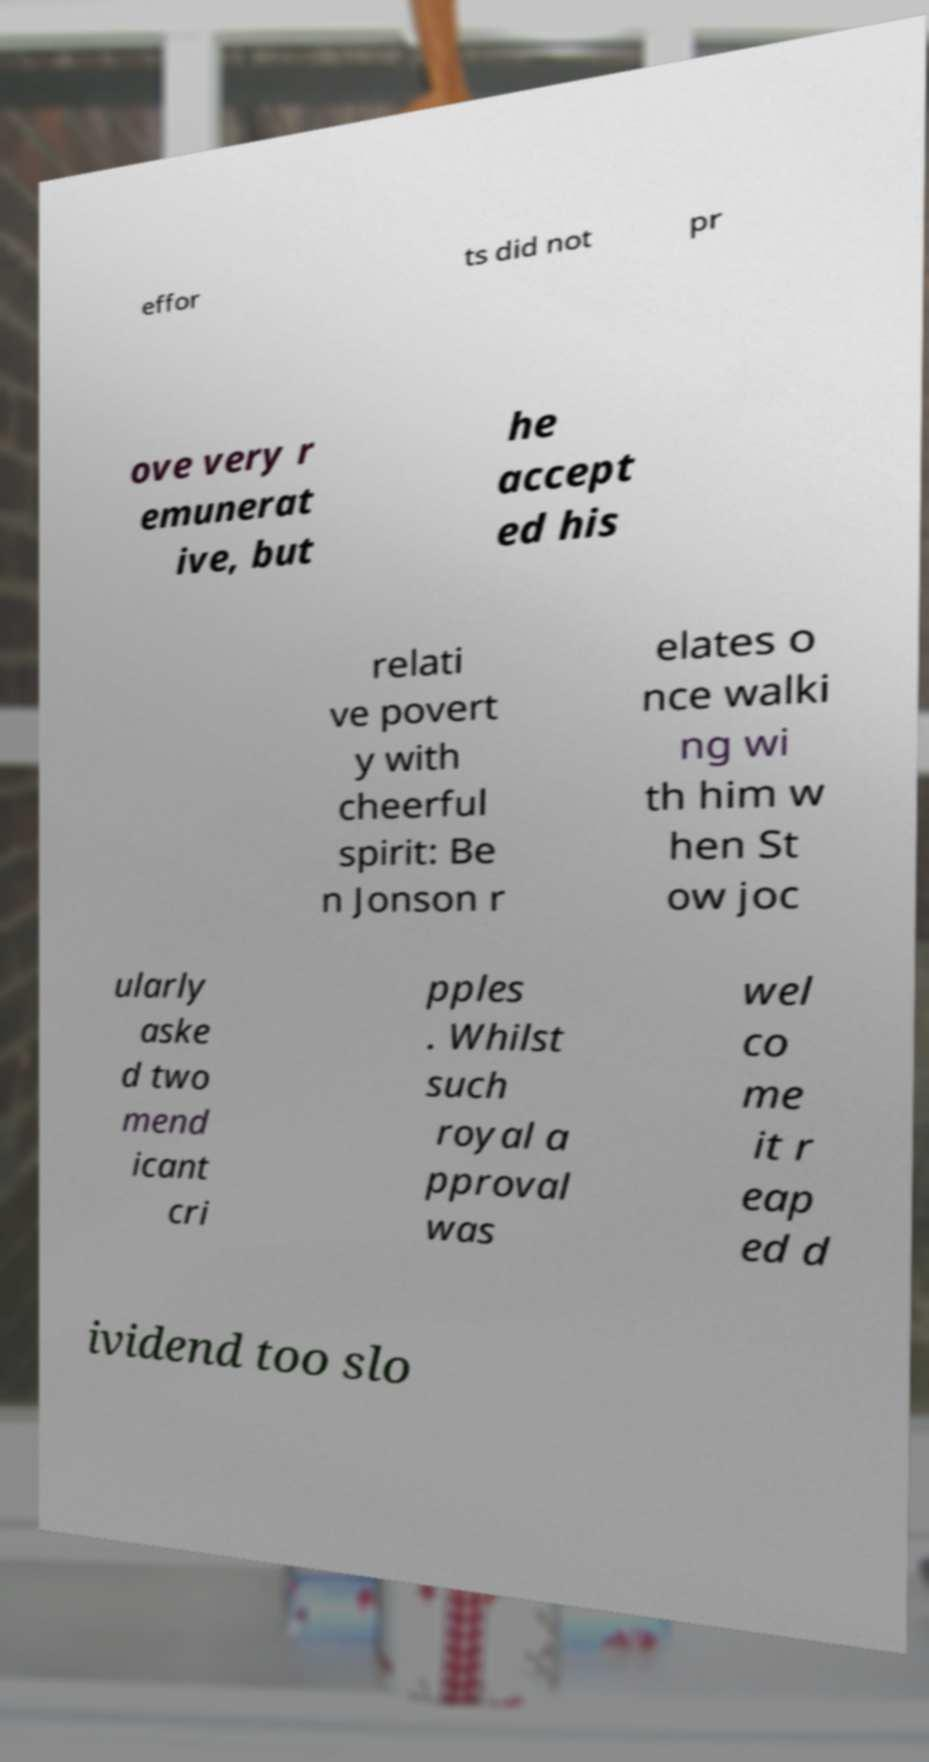I need the written content from this picture converted into text. Can you do that? effor ts did not pr ove very r emunerat ive, but he accept ed his relati ve povert y with cheerful spirit: Be n Jonson r elates o nce walki ng wi th him w hen St ow joc ularly aske d two mend icant cri pples . Whilst such royal a pproval was wel co me it r eap ed d ividend too slo 